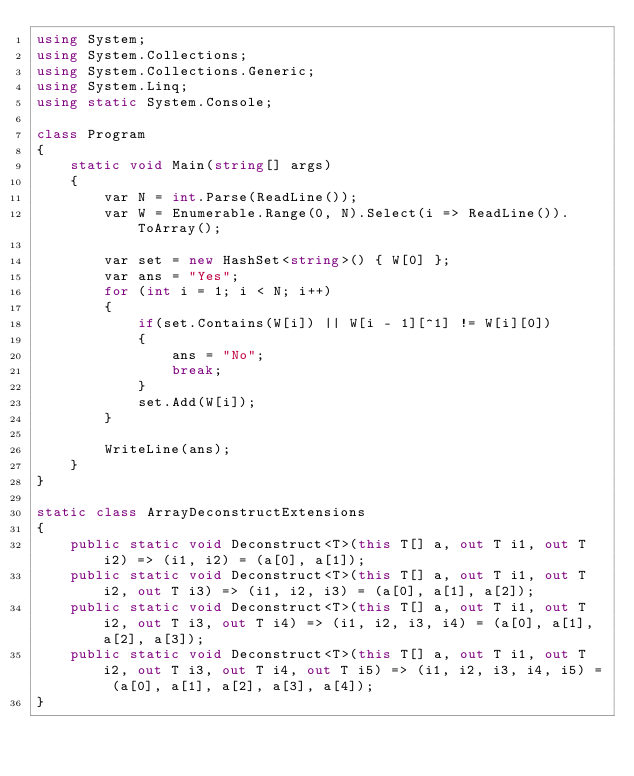<code> <loc_0><loc_0><loc_500><loc_500><_C#_>using System;
using System.Collections;
using System.Collections.Generic;
using System.Linq;
using static System.Console;

class Program
{
    static void Main(string[] args)
    {
        var N = int.Parse(ReadLine());
        var W = Enumerable.Range(0, N).Select(i => ReadLine()).ToArray();

        var set = new HashSet<string>() { W[0] };
        var ans = "Yes";
        for (int i = 1; i < N; i++)
        {
            if(set.Contains(W[i]) || W[i - 1][^1] != W[i][0])
            {
                ans = "No";
                break;
            }
            set.Add(W[i]);
        }

        WriteLine(ans);
    }
}

static class ArrayDeconstructExtensions
{
    public static void Deconstruct<T>(this T[] a, out T i1, out T i2) => (i1, i2) = (a[0], a[1]);
    public static void Deconstruct<T>(this T[] a, out T i1, out T i2, out T i3) => (i1, i2, i3) = (a[0], a[1], a[2]);
    public static void Deconstruct<T>(this T[] a, out T i1, out T i2, out T i3, out T i4) => (i1, i2, i3, i4) = (a[0], a[1], a[2], a[3]);
    public static void Deconstruct<T>(this T[] a, out T i1, out T i2, out T i3, out T i4, out T i5) => (i1, i2, i3, i4, i5) = (a[0], a[1], a[2], a[3], a[4]);
}
</code> 